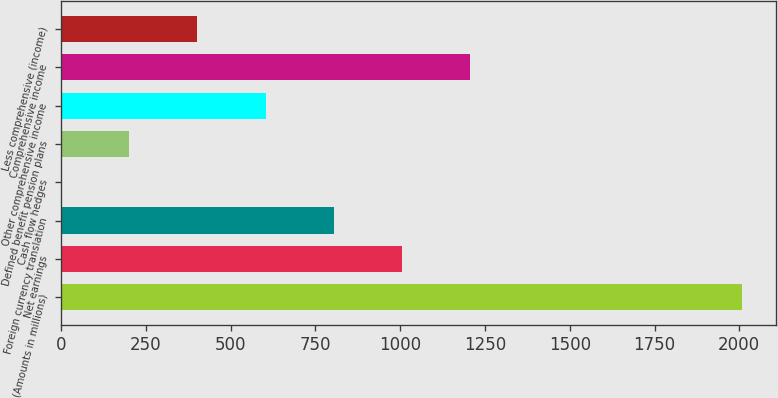Convert chart to OTSL. <chart><loc_0><loc_0><loc_500><loc_500><bar_chart><fcel>(Amounts in millions)<fcel>Net earnings<fcel>Foreign currency translation<fcel>Cash flow hedges<fcel>Defined benefit pension plans<fcel>Other comprehensive income<fcel>Comprehensive income<fcel>Less comprehensive (income)<nl><fcel>2009<fcel>1004.7<fcel>803.84<fcel>0.4<fcel>201.26<fcel>602.98<fcel>1205.56<fcel>402.12<nl></chart> 